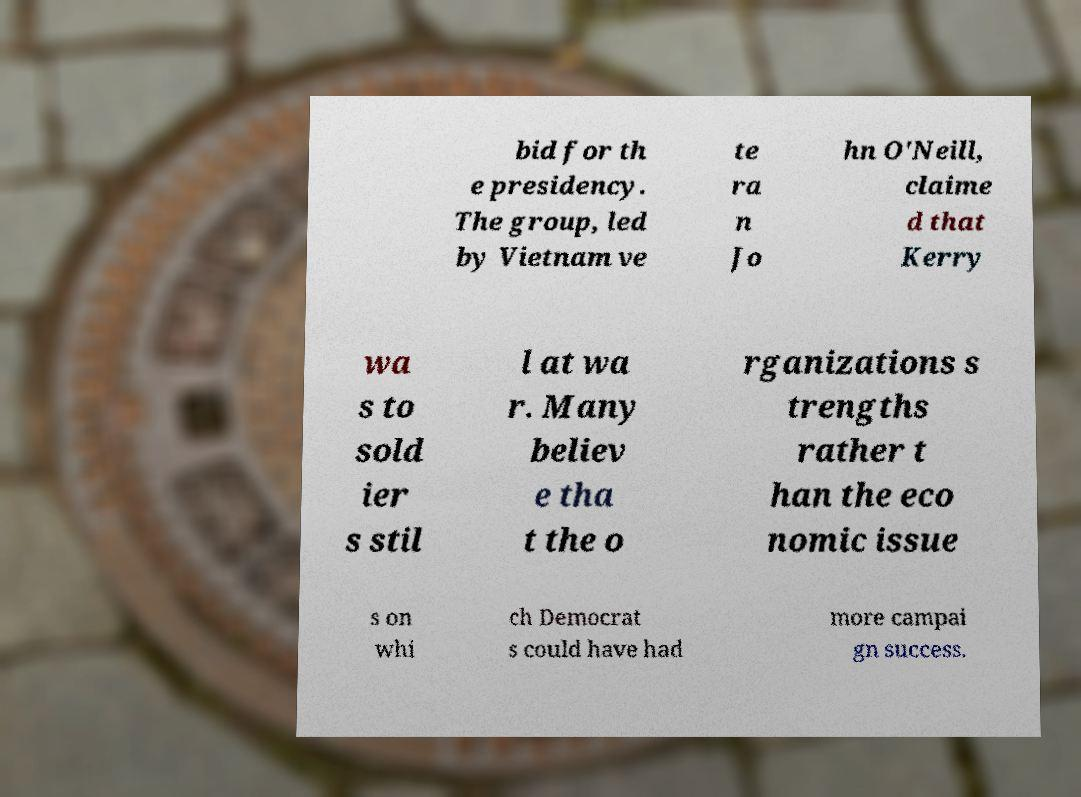Please identify and transcribe the text found in this image. bid for th e presidency. The group, led by Vietnam ve te ra n Jo hn O'Neill, claime d that Kerry wa s to sold ier s stil l at wa r. Many believ e tha t the o rganizations s trengths rather t han the eco nomic issue s on whi ch Democrat s could have had more campai gn success. 